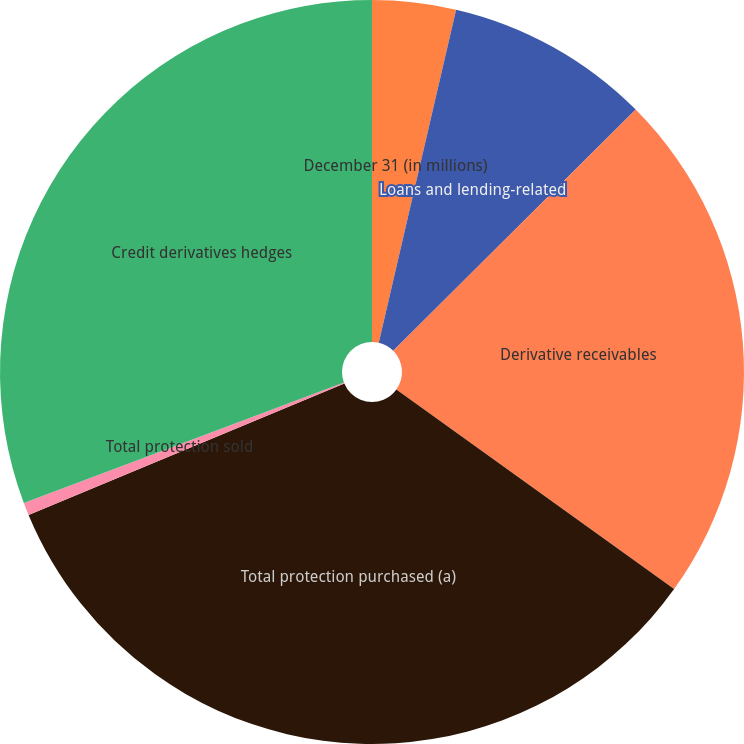Convert chart to OTSL. <chart><loc_0><loc_0><loc_500><loc_500><pie_chart><fcel>December 31 (in millions)<fcel>Loans and lending-related<fcel>Derivative receivables<fcel>Total protection purchased (a)<fcel>Total protection sold<fcel>Credit derivatives hedges<nl><fcel>3.63%<fcel>8.91%<fcel>22.38%<fcel>33.81%<fcel>0.55%<fcel>30.73%<nl></chart> 